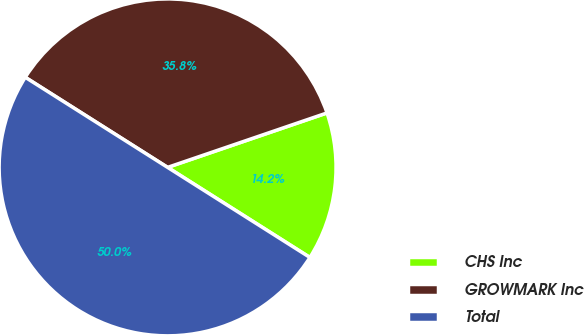<chart> <loc_0><loc_0><loc_500><loc_500><pie_chart><fcel>CHS Inc<fcel>GROWMARK Inc<fcel>Total<nl><fcel>14.22%<fcel>35.78%<fcel>50.0%<nl></chart> 